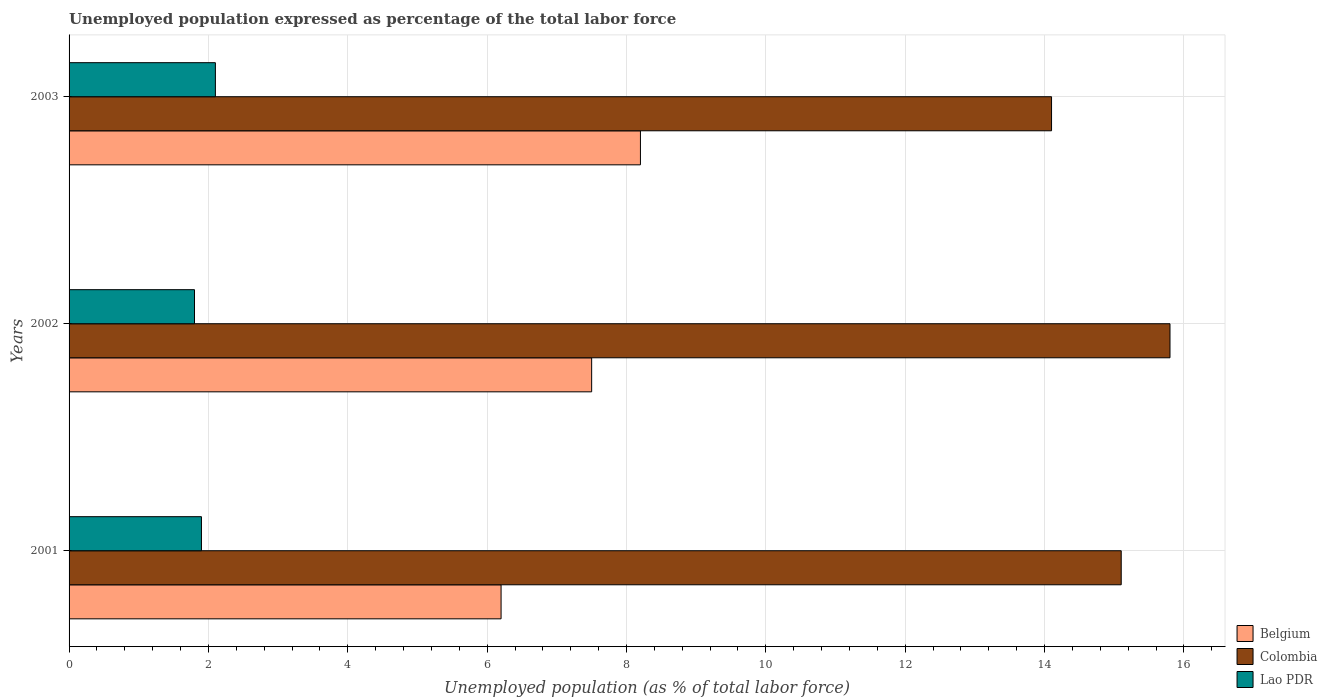Are the number of bars per tick equal to the number of legend labels?
Provide a short and direct response. Yes. How many bars are there on the 1st tick from the top?
Provide a succinct answer. 3. What is the label of the 1st group of bars from the top?
Your answer should be compact. 2003. What is the unemployment in in Colombia in 2003?
Offer a very short reply. 14.1. Across all years, what is the maximum unemployment in in Lao PDR?
Offer a terse response. 2.1. Across all years, what is the minimum unemployment in in Colombia?
Offer a very short reply. 14.1. In which year was the unemployment in in Belgium maximum?
Provide a short and direct response. 2003. In which year was the unemployment in in Lao PDR minimum?
Keep it short and to the point. 2002. What is the total unemployment in in Belgium in the graph?
Keep it short and to the point. 21.9. What is the difference between the unemployment in in Lao PDR in 2001 and that in 2002?
Offer a terse response. 0.1. What is the difference between the unemployment in in Lao PDR in 2001 and the unemployment in in Colombia in 2002?
Offer a very short reply. -13.9. What is the average unemployment in in Lao PDR per year?
Provide a succinct answer. 1.93. In the year 2003, what is the difference between the unemployment in in Colombia and unemployment in in Lao PDR?
Provide a succinct answer. 12. In how many years, is the unemployment in in Belgium greater than 10.8 %?
Offer a terse response. 0. What is the ratio of the unemployment in in Lao PDR in 2001 to that in 2003?
Your response must be concise. 0.9. What is the difference between the highest and the second highest unemployment in in Colombia?
Offer a very short reply. 0.7. What is the difference between the highest and the lowest unemployment in in Colombia?
Provide a succinct answer. 1.7. What does the 2nd bar from the top in 2003 represents?
Your answer should be very brief. Colombia. What does the 3rd bar from the bottom in 2001 represents?
Give a very brief answer. Lao PDR. Are all the bars in the graph horizontal?
Provide a succinct answer. Yes. How many years are there in the graph?
Your answer should be compact. 3. Are the values on the major ticks of X-axis written in scientific E-notation?
Offer a very short reply. No. Does the graph contain grids?
Offer a terse response. Yes. Where does the legend appear in the graph?
Offer a very short reply. Bottom right. How many legend labels are there?
Offer a very short reply. 3. What is the title of the graph?
Your answer should be very brief. Unemployed population expressed as percentage of the total labor force. What is the label or title of the X-axis?
Ensure brevity in your answer.  Unemployed population (as % of total labor force). What is the Unemployed population (as % of total labor force) of Belgium in 2001?
Your answer should be compact. 6.2. What is the Unemployed population (as % of total labor force) of Colombia in 2001?
Ensure brevity in your answer.  15.1. What is the Unemployed population (as % of total labor force) in Lao PDR in 2001?
Your response must be concise. 1.9. What is the Unemployed population (as % of total labor force) in Colombia in 2002?
Your response must be concise. 15.8. What is the Unemployed population (as % of total labor force) in Lao PDR in 2002?
Give a very brief answer. 1.8. What is the Unemployed population (as % of total labor force) in Belgium in 2003?
Your response must be concise. 8.2. What is the Unemployed population (as % of total labor force) in Colombia in 2003?
Offer a terse response. 14.1. What is the Unemployed population (as % of total labor force) in Lao PDR in 2003?
Your response must be concise. 2.1. Across all years, what is the maximum Unemployed population (as % of total labor force) of Belgium?
Ensure brevity in your answer.  8.2. Across all years, what is the maximum Unemployed population (as % of total labor force) of Colombia?
Offer a terse response. 15.8. Across all years, what is the maximum Unemployed population (as % of total labor force) of Lao PDR?
Offer a very short reply. 2.1. Across all years, what is the minimum Unemployed population (as % of total labor force) of Belgium?
Give a very brief answer. 6.2. Across all years, what is the minimum Unemployed population (as % of total labor force) of Colombia?
Provide a short and direct response. 14.1. Across all years, what is the minimum Unemployed population (as % of total labor force) of Lao PDR?
Give a very brief answer. 1.8. What is the total Unemployed population (as % of total labor force) of Belgium in the graph?
Your response must be concise. 21.9. What is the total Unemployed population (as % of total labor force) in Colombia in the graph?
Make the answer very short. 45. What is the total Unemployed population (as % of total labor force) of Lao PDR in the graph?
Provide a short and direct response. 5.8. What is the difference between the Unemployed population (as % of total labor force) of Lao PDR in 2002 and that in 2003?
Ensure brevity in your answer.  -0.3. What is the difference between the Unemployed population (as % of total labor force) of Colombia in 2001 and the Unemployed population (as % of total labor force) of Lao PDR in 2003?
Give a very brief answer. 13. What is the difference between the Unemployed population (as % of total labor force) in Belgium in 2002 and the Unemployed population (as % of total labor force) in Colombia in 2003?
Provide a short and direct response. -6.6. What is the difference between the Unemployed population (as % of total labor force) of Belgium in 2002 and the Unemployed population (as % of total labor force) of Lao PDR in 2003?
Your answer should be compact. 5.4. What is the difference between the Unemployed population (as % of total labor force) of Colombia in 2002 and the Unemployed population (as % of total labor force) of Lao PDR in 2003?
Ensure brevity in your answer.  13.7. What is the average Unemployed population (as % of total labor force) in Belgium per year?
Your answer should be compact. 7.3. What is the average Unemployed population (as % of total labor force) in Colombia per year?
Provide a succinct answer. 15. What is the average Unemployed population (as % of total labor force) in Lao PDR per year?
Keep it short and to the point. 1.93. In the year 2001, what is the difference between the Unemployed population (as % of total labor force) in Belgium and Unemployed population (as % of total labor force) in Colombia?
Keep it short and to the point. -8.9. In the year 2001, what is the difference between the Unemployed population (as % of total labor force) of Belgium and Unemployed population (as % of total labor force) of Lao PDR?
Offer a terse response. 4.3. In the year 2001, what is the difference between the Unemployed population (as % of total labor force) in Colombia and Unemployed population (as % of total labor force) in Lao PDR?
Make the answer very short. 13.2. In the year 2002, what is the difference between the Unemployed population (as % of total labor force) in Belgium and Unemployed population (as % of total labor force) in Colombia?
Your answer should be very brief. -8.3. In the year 2002, what is the difference between the Unemployed population (as % of total labor force) in Belgium and Unemployed population (as % of total labor force) in Lao PDR?
Offer a terse response. 5.7. In the year 2002, what is the difference between the Unemployed population (as % of total labor force) in Colombia and Unemployed population (as % of total labor force) in Lao PDR?
Your response must be concise. 14. In the year 2003, what is the difference between the Unemployed population (as % of total labor force) of Belgium and Unemployed population (as % of total labor force) of Lao PDR?
Give a very brief answer. 6.1. What is the ratio of the Unemployed population (as % of total labor force) in Belgium in 2001 to that in 2002?
Provide a short and direct response. 0.83. What is the ratio of the Unemployed population (as % of total labor force) of Colombia in 2001 to that in 2002?
Keep it short and to the point. 0.96. What is the ratio of the Unemployed population (as % of total labor force) in Lao PDR in 2001 to that in 2002?
Give a very brief answer. 1.06. What is the ratio of the Unemployed population (as % of total labor force) of Belgium in 2001 to that in 2003?
Your response must be concise. 0.76. What is the ratio of the Unemployed population (as % of total labor force) of Colombia in 2001 to that in 2003?
Offer a terse response. 1.07. What is the ratio of the Unemployed population (as % of total labor force) of Lao PDR in 2001 to that in 2003?
Provide a short and direct response. 0.9. What is the ratio of the Unemployed population (as % of total labor force) of Belgium in 2002 to that in 2003?
Provide a succinct answer. 0.91. What is the ratio of the Unemployed population (as % of total labor force) of Colombia in 2002 to that in 2003?
Offer a terse response. 1.12. What is the difference between the highest and the second highest Unemployed population (as % of total labor force) of Belgium?
Your response must be concise. 0.7. What is the difference between the highest and the second highest Unemployed population (as % of total labor force) of Colombia?
Offer a very short reply. 0.7. What is the difference between the highest and the lowest Unemployed population (as % of total labor force) of Belgium?
Your answer should be compact. 2. What is the difference between the highest and the lowest Unemployed population (as % of total labor force) in Colombia?
Your answer should be very brief. 1.7. What is the difference between the highest and the lowest Unemployed population (as % of total labor force) in Lao PDR?
Ensure brevity in your answer.  0.3. 